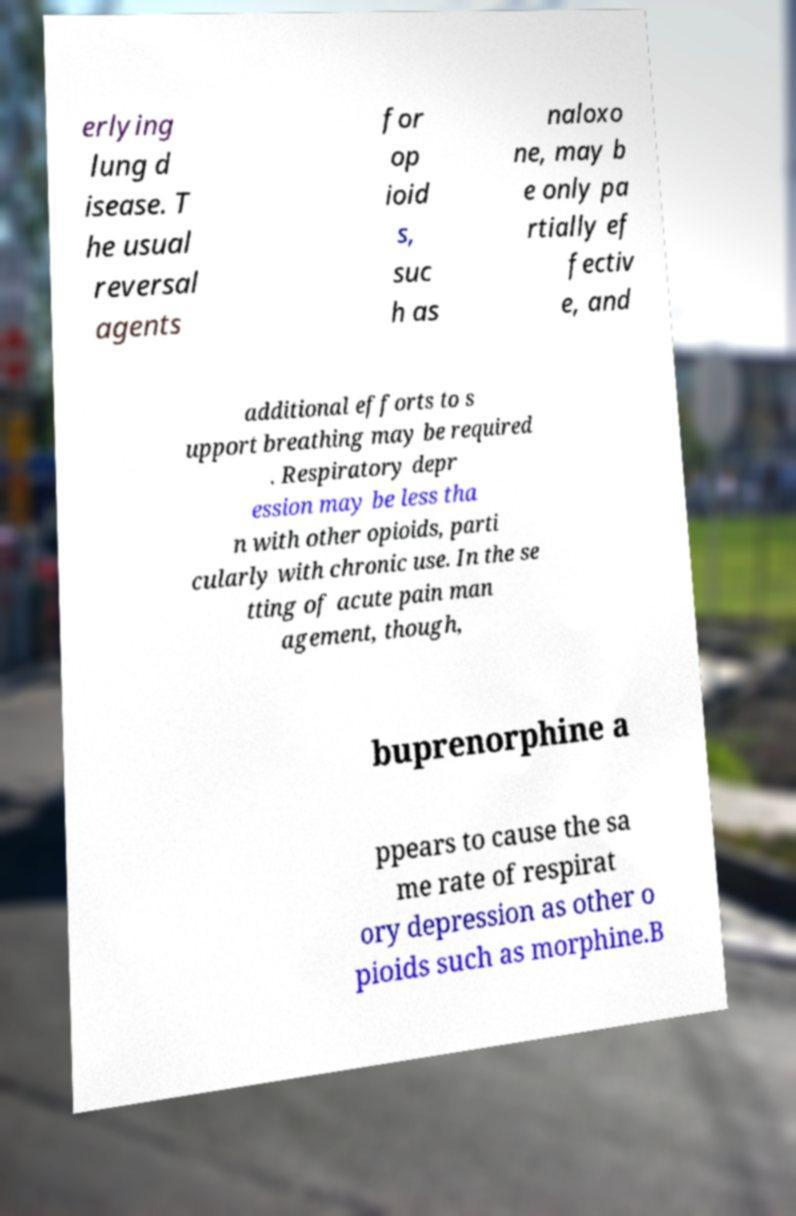Could you assist in decoding the text presented in this image and type it out clearly? erlying lung d isease. T he usual reversal agents for op ioid s, suc h as naloxo ne, may b e only pa rtially ef fectiv e, and additional efforts to s upport breathing may be required . Respiratory depr ession may be less tha n with other opioids, parti cularly with chronic use. In the se tting of acute pain man agement, though, buprenorphine a ppears to cause the sa me rate of respirat ory depression as other o pioids such as morphine.B 